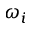Convert formula to latex. <formula><loc_0><loc_0><loc_500><loc_500>\omega _ { i }</formula> 